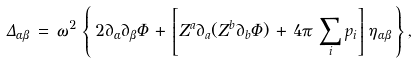Convert formula to latex. <formula><loc_0><loc_0><loc_500><loc_500>\Delta _ { \alpha \beta } \, = \, \omega ^ { 2 } \, \left \{ \, 2 \partial _ { \alpha } \partial _ { \beta } \Phi \, + \, \left [ Z ^ { a } \partial _ { a } ( Z ^ { b } \partial _ { b } \Phi ) \, + \, 4 \pi \, \sum _ { i } p _ { i } \right ] \, \eta _ { \alpha \beta } \, \right \} ,</formula> 